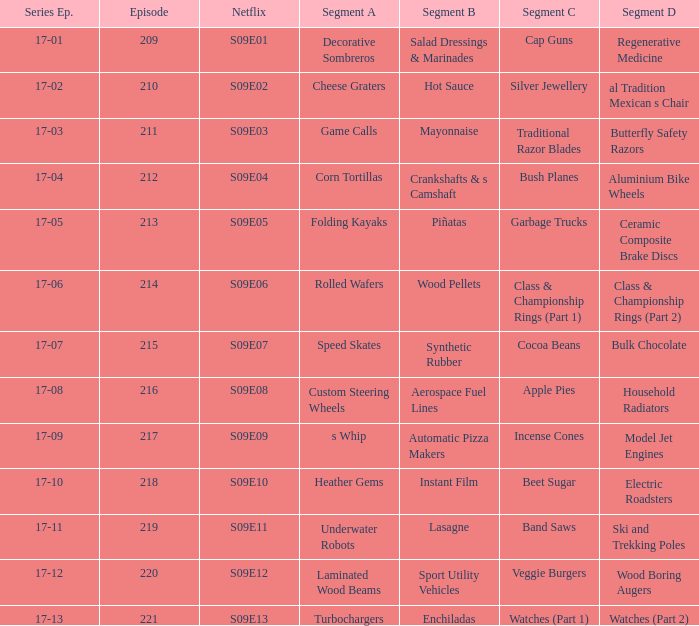What was segment c in an episode smaller than 210? Cap Guns. 